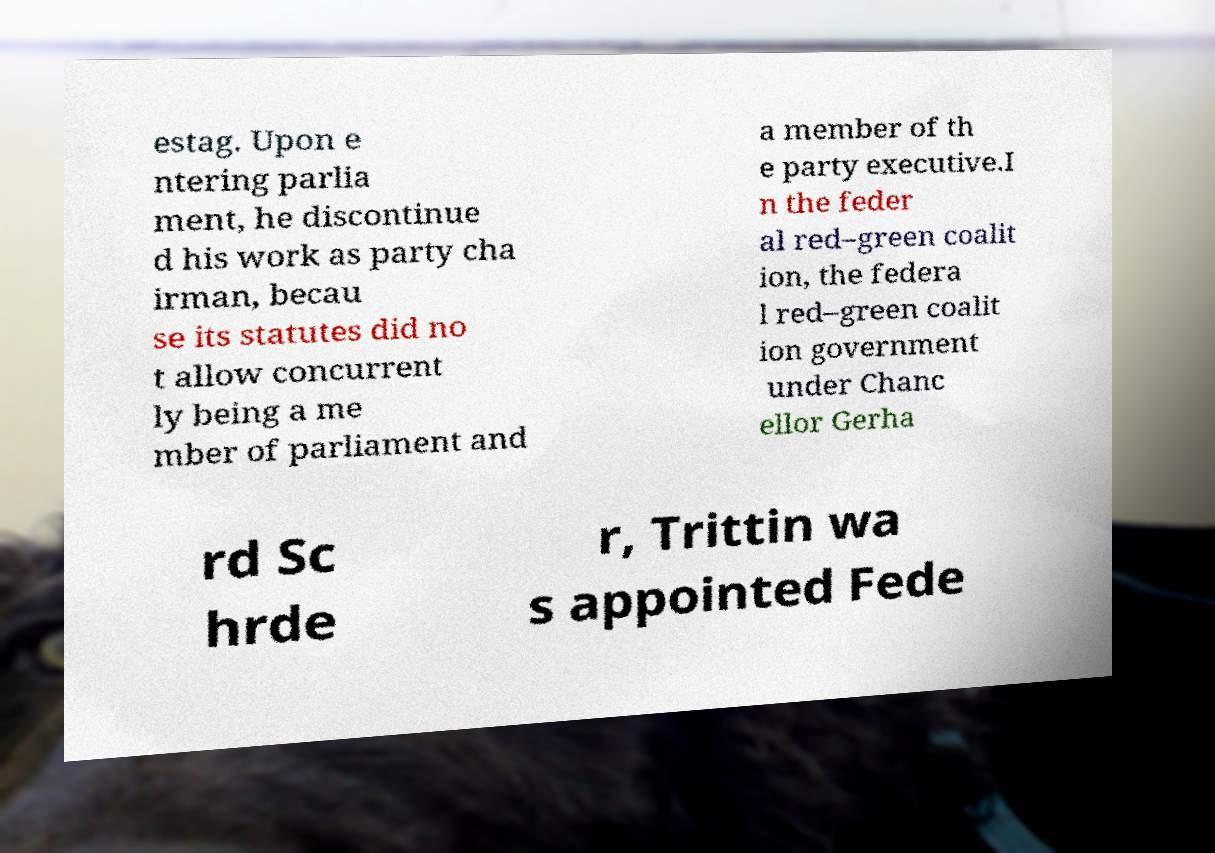What messages or text are displayed in this image? I need them in a readable, typed format. estag. Upon e ntering parlia ment, he discontinue d his work as party cha irman, becau se its statutes did no t allow concurrent ly being a me mber of parliament and a member of th e party executive.I n the feder al red–green coalit ion, the federa l red–green coalit ion government under Chanc ellor Gerha rd Sc hrde r, Trittin wa s appointed Fede 